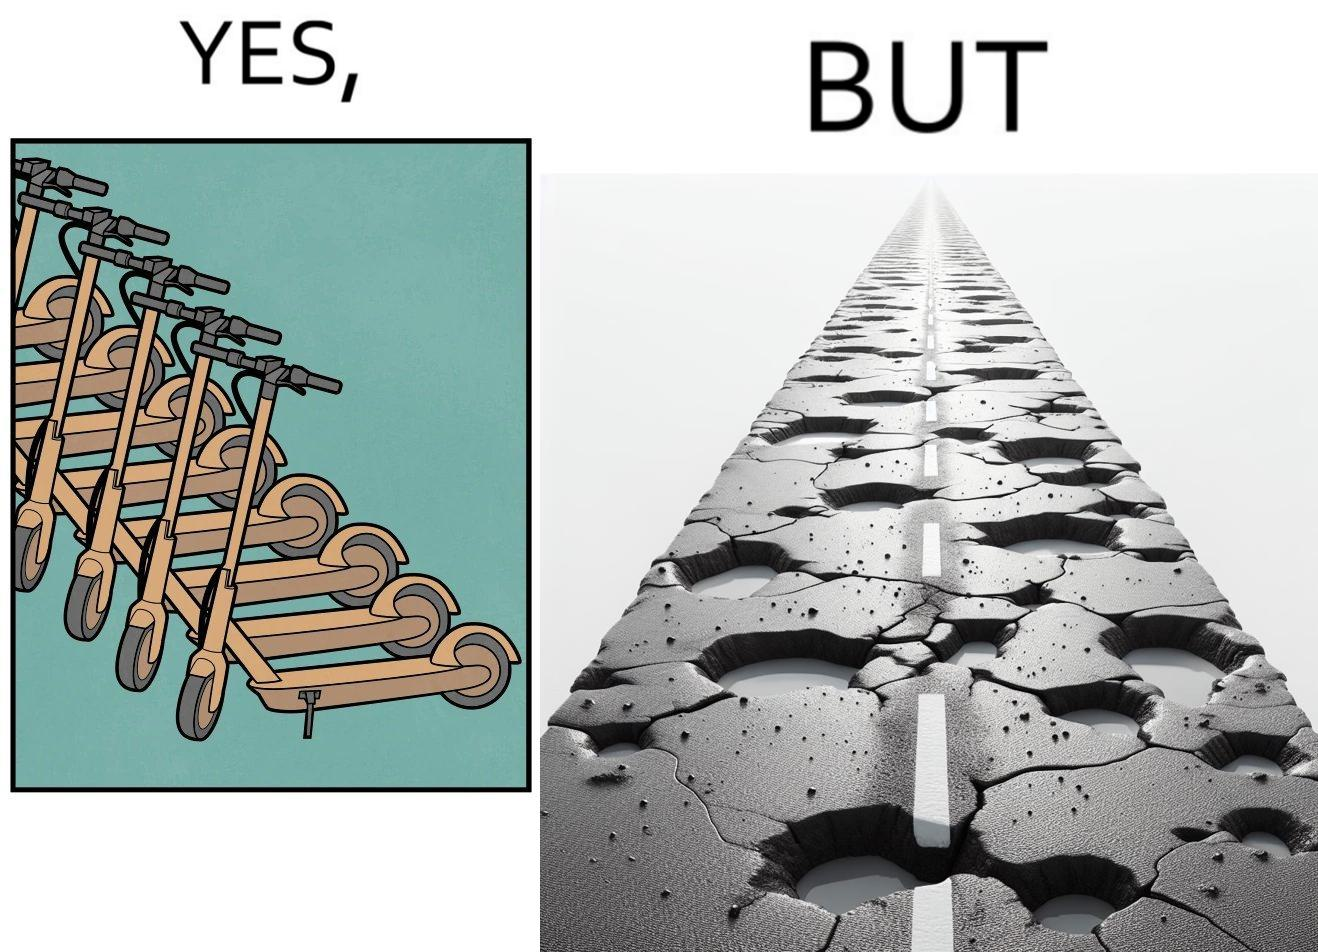What does this image depict? The image is ironic, because even after when the skateboard scooters are available for someone to ride but the road has many potholes that it is not suitable to ride the scooters on such roads 